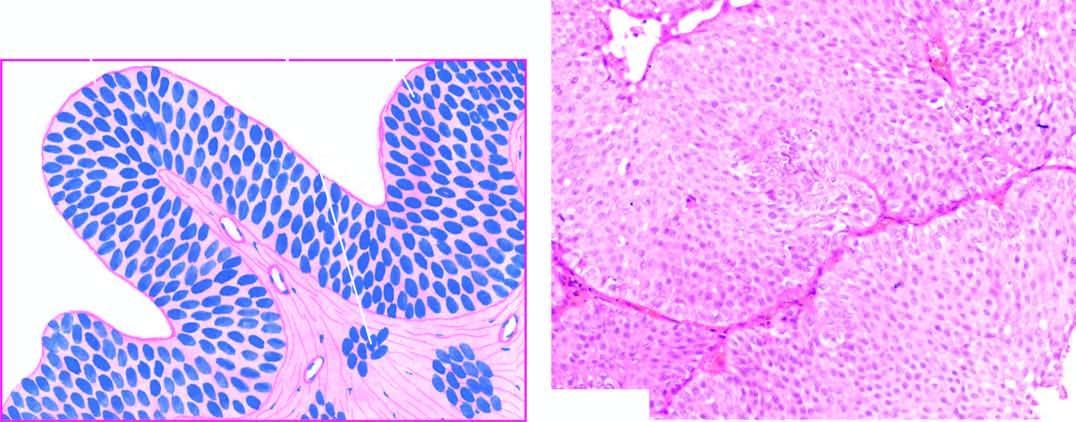what is there in the number of layers of epithelium?
Answer the question using a single word or phrase. Increase 